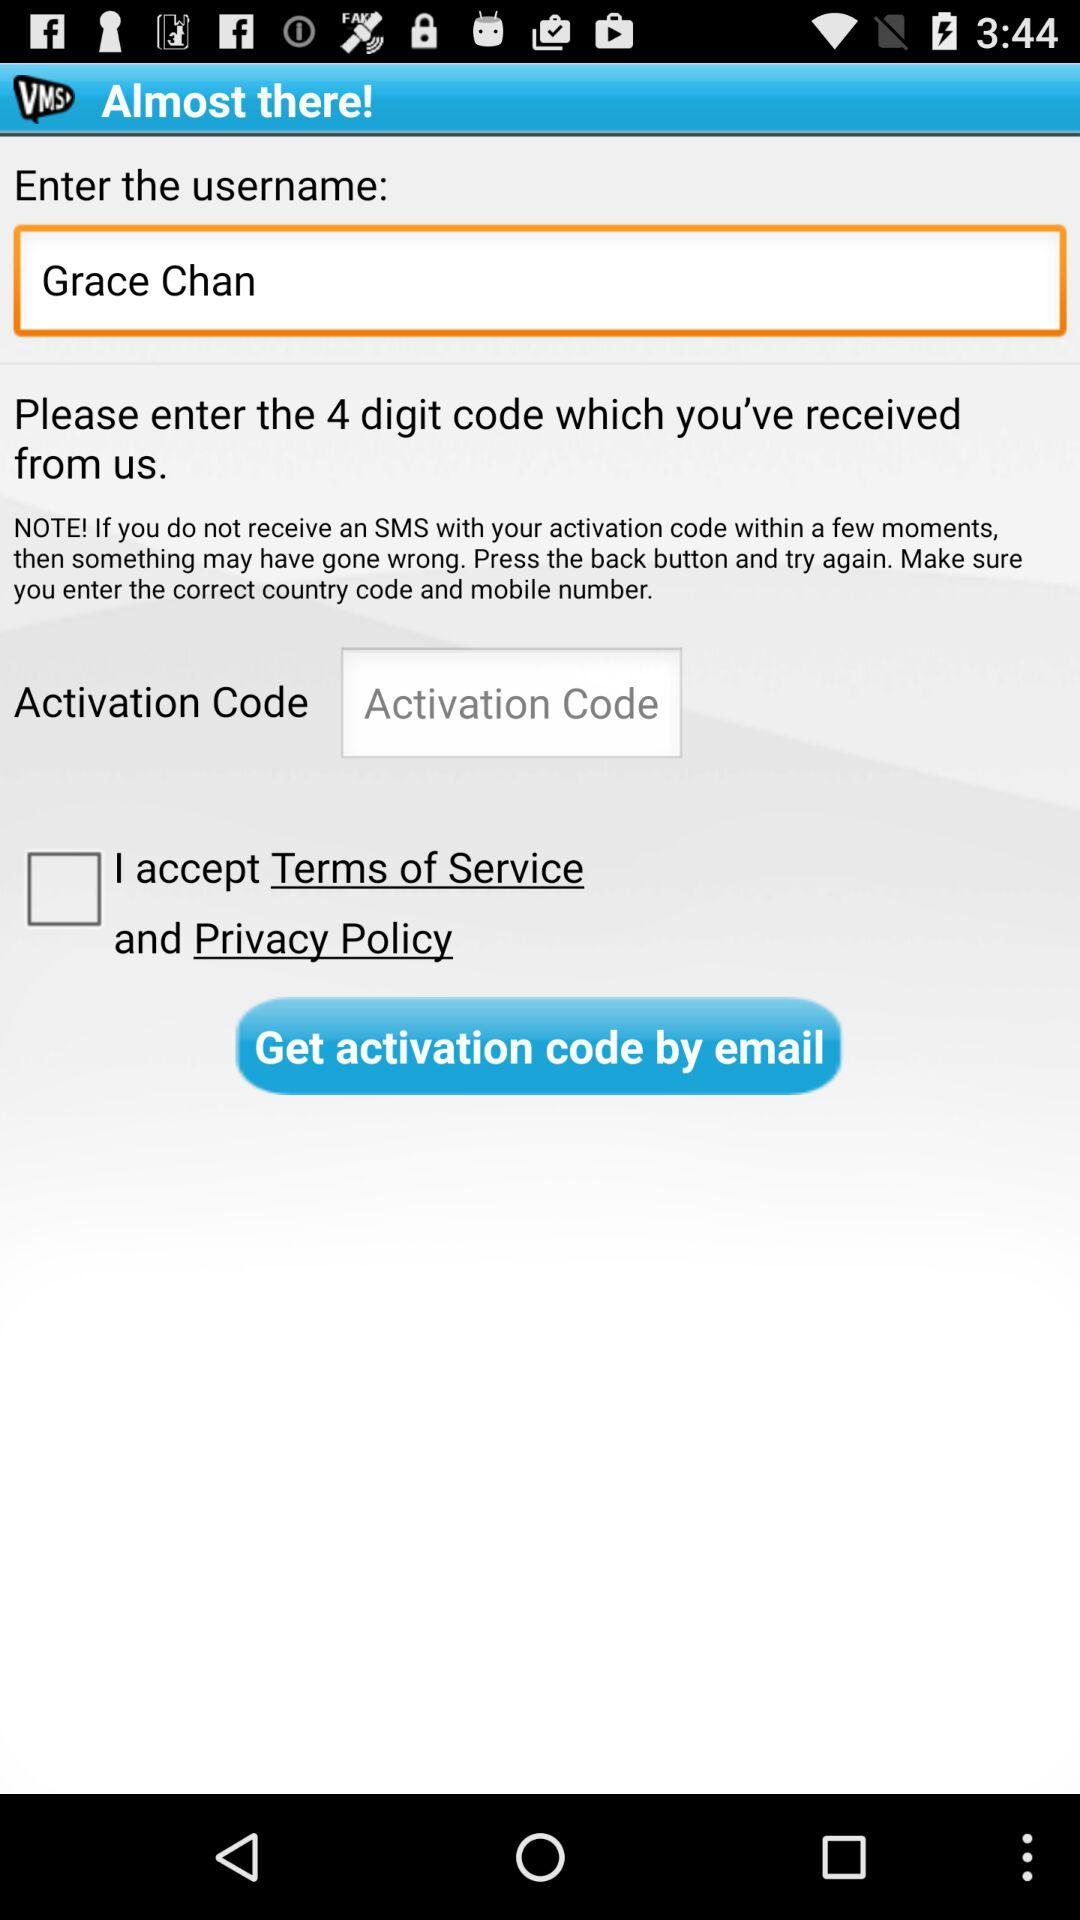Which step are you currently on? You are currently on Step 1. 